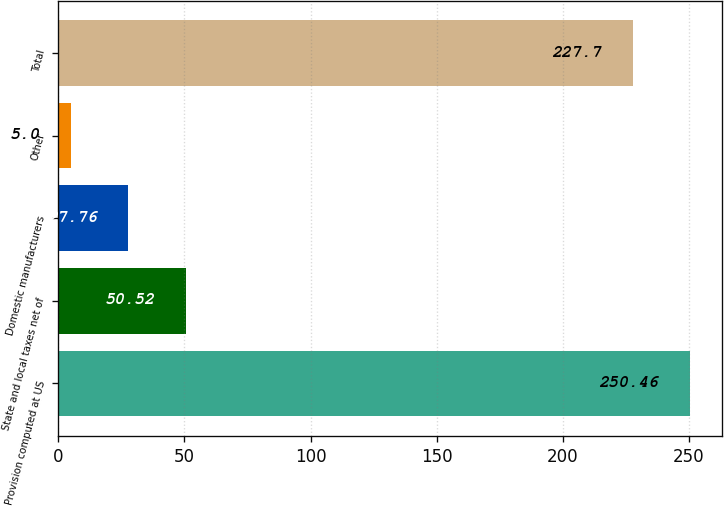Convert chart to OTSL. <chart><loc_0><loc_0><loc_500><loc_500><bar_chart><fcel>Provision computed at US<fcel>State and local taxes net of<fcel>Domestic manufacturers<fcel>Other<fcel>Total<nl><fcel>250.46<fcel>50.52<fcel>27.76<fcel>5<fcel>227.7<nl></chart> 